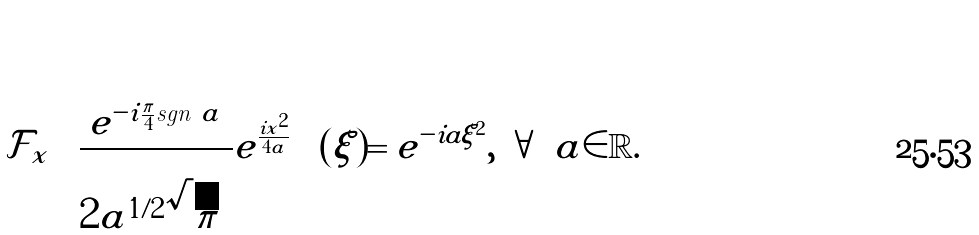Convert formula to latex. <formula><loc_0><loc_0><loc_500><loc_500>\mathcal { F } _ { x } \left ( \frac { e ^ { - i \frac { \pi } { 4 } \text {sgn} \ a } } { 2 | a | ^ { 1 / 2 } \sqrt { \pi } } e ^ { \frac { i x ^ { 2 } } { 4 a } } \right ) ( \xi ) = e ^ { - i a \xi ^ { 2 } } , \ \forall \ a \in \mathbb { R } .</formula> 